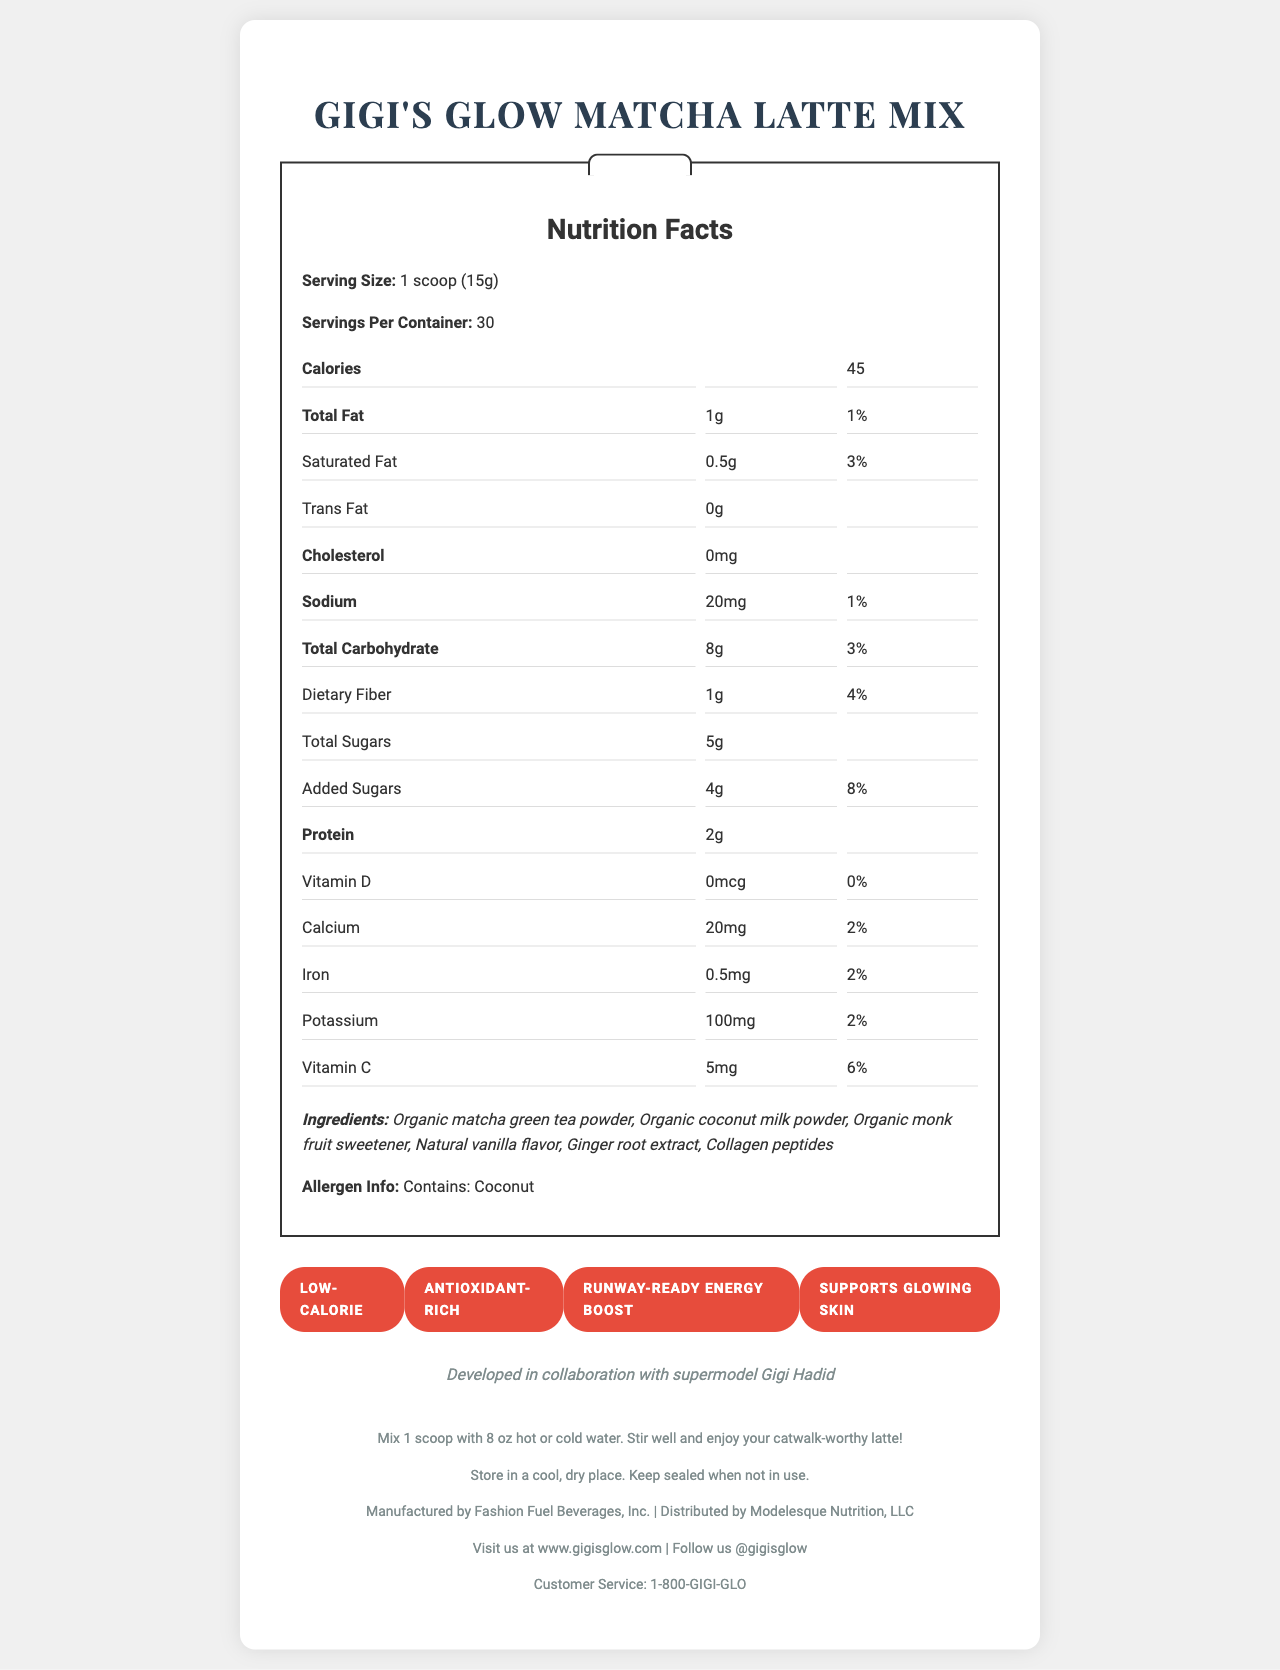what is the serving size of Gigi's Glow Matcha Latte Mix? The serving size is listed as "1 scoop (15g)" in the nutrition facts section of the document.
Answer: 1 scoop (15g) how many calories are in each serving? The document clearly states that there are 45 calories per serving.
Answer: 45 calories what is the total carbohydrate content per serving? The total carbohydrate content is listed as 8g per serving in the nutrition facts.
Answer: 8g how much protein is in one serving of the matcha latte mix? The nutrition facts indicate that one serving contains 2g of protein.
Answer: 2g what vitamins and minerals are present in Gigi's Glow Matcha Latte Mix? The document lists Vitamin D, Calcium, Iron, Potassium, and Vitamin C along with their respective amounts and daily values.
Answer: Vitamin D, Calcium, Iron, Potassium, Vitamin C which ingredient(s) could be a potential allergen? The allergen information section specifically mentions coconut as a potential allergen.
Answer: Coconut who collaborated in developing this product? A. Kendall Jenner B. Gigi Hadid C. Emily Ratajkowski D. Bella Hadid The document states that the product was developed in collaboration with supermodel Gigi Hadid.
Answer: B. Gigi Hadid how much added sugar does each serving contain? The nutrition facts section indicates that each serving contains 4g of added sugars.
Answer: 4g what is the manufacturer of Gigi's Glow Matcha Latte Mix? A. Modelesque Nutrition B. Fashion Fuel Beverages, Inc. C. Glamour Eats D. Refresh Foods The document indicates that the product is manufactured by Fashion Fuel Beverages, Inc.
Answer: B. Fashion Fuel Beverages, Inc. does the product support glowing skin? One of the product claims listed is "Supports glowing skin".
Answer: Yes describe the main idea of the document. The document is primarily focused on presenting all necessary information regarding the matcha latte mix, covering its nutritional value, benefits, and usage details, as well as associating it with a celebrity endorsement to boost its appeal.
Answer: The document provides comprehensive details about Gigi's Glow Matcha Latte Mix, including its nutritional facts, ingredients, allergen information, celebrity endorsement, product claims, preparation and storage instructions, manufacturer, distributor, and contact information. what is the social media handle for Gigi's Glow Matcha Latte Mix? The social media handle for Gigi's Glow Matcha Latte Mix is listed as @gigisglow in the footer section of the document.
Answer: @gigisglow how many servings are there in one container? The document states that there are 30 servings per container in the nutrition facts section.
Answer: 30 servings what are the preparation instructions for the matcha latte mix? The preparation instructions are clearly provided in the footer section of the document.
Answer: Mix 1 scoop with 8 oz hot or cold water. Stir well and enjoy your catwalk-worthy latte! how much vitamin D does the matcha latte mix contain per serving? The nutrition facts indicate that there is 0mcg of vitamin D per serving.
Answer: 0mcg what is the product's website? The website for the product is listed as www.gigisglow.com in the footer of the document.
Answer: www.gigisglow.com how much collagen peptides are in each serving? The document lists collagen peptides as an ingredient but does not specify the amount per serving.
Answer: Not enough information 